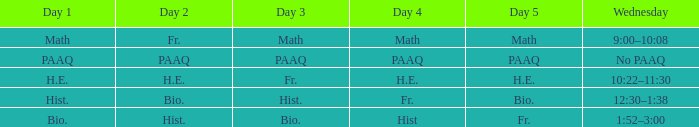What is the day 1 when day 5 is math? Math. 